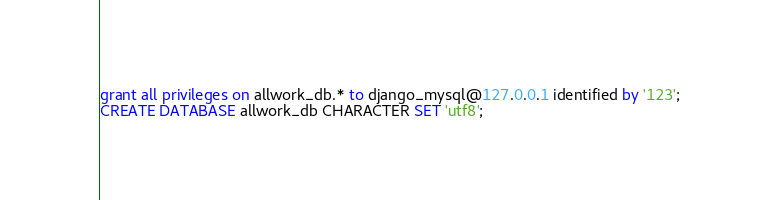<code> <loc_0><loc_0><loc_500><loc_500><_SQL_>grant all privileges on allwork_db.* to django_mysql@127.0.0.1 identified by '123';
CREATE DATABASE allwork_db CHARACTER SET 'utf8';</code> 